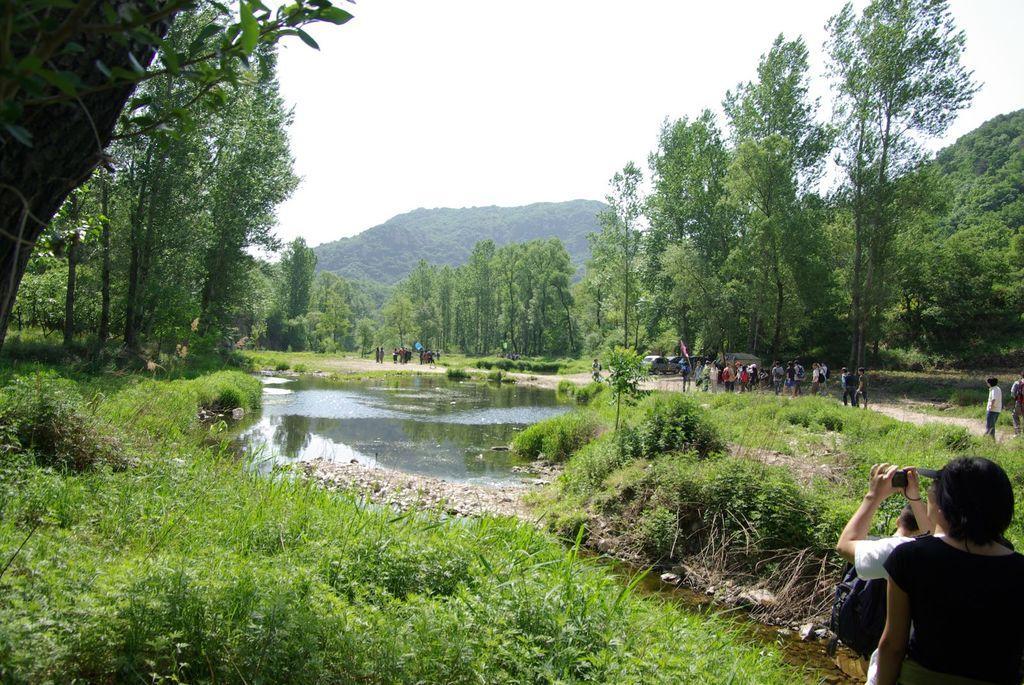Describe this image in one or two sentences. In this image, we can see there are groups of people and a person is holding a camera. At the bottom of the image, there are plants. In front of the plants there is water, trees and hills. At the top of the image, there is the sky. 